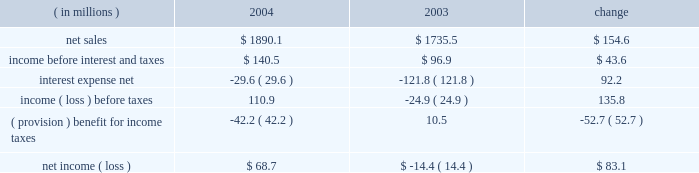Instruments at fair value and to recognize the effective and ineffective portions of the cash flow hedges .
( 2 ) for the year ended december 31 , 2000 , earnings available to common stockholders includes reductions of $ 2371 of preferred stock dividends and $ 16266 for the redemption of pca 2019s 123 20448% ( 20448 % ) preferred stock .
( 3 ) on october 13 , 2003 , pca announced its intention to begin paying a quarterly cash dividend of $ 0.15 per share , or $ 0.60 per share annually , on its common stock .
The first quarterly dividend of $ 0.15 per share was paid on january 15 , 2004 to shareholders of record as of december 15 , 2003 .
Pca did not declare any dividends on its common stock in 2000 - 2002 .
( 4 ) total long-term obligations include long-term debt , short-term debt and the current maturities of long-term debt .
Item 7 .
Management 2019s discussion and analysis of financial condition and results of operations the following discussion of historical results of operations and financial condition should be read in conjunction with the audited financial statements and the notes thereto which appear elsewhere in this report .
Overview on april 12 , 1999 , pca acquired the containerboard and corrugated products business of pactiv corporation ( the 201cgroup 201d ) , formerly known as tenneco packaging inc. , a wholly owned subsidiary of tenneco , inc .
The group operated prior to april 12 , 1999 as a division of pactiv , and not as a separate , stand-alone entity .
From its formation in january 1999 and through the closing of the acquisition on april 12 , 1999 , pca did not have any significant operations .
The april 12 , 1999 acquisition was accounted for using historical values for the contributed assets .
Purchase accounting was not applied because , under the applicable accounting guidance , a change of control was deemed not to have occurred as a result of the participating veto rights held by pactiv after the closing of the transactions under the terms of the stockholders agreement entered into in connection with the transactions .
Results of operations year ended december 31 , 2004 compared to year ended december 31 , 2003 the historical results of operations of pca for the years ended december , 31 2004 and 2003 are set forth the below : for the year ended december 31 , ( in millions ) 2004 2003 change .

What was the percentage change in income before interest and taxes between 2003 and 2004? 
Computations: (43.6 / 96.9)
Answer: 0.44995. 